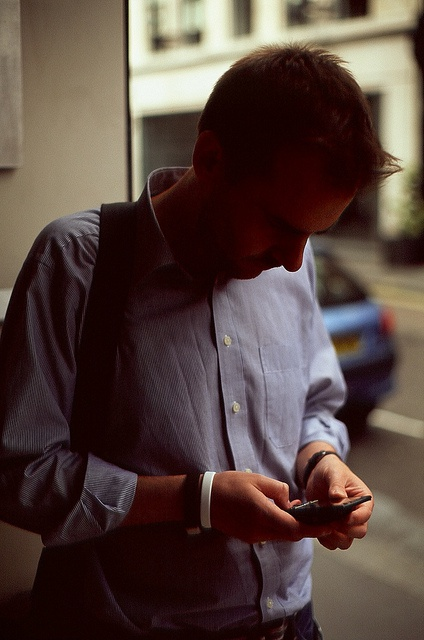Describe the objects in this image and their specific colors. I can see people in gray, black, darkgray, and maroon tones, backpack in gray and black tones, car in gray, black, and maroon tones, and cell phone in gray, black, maroon, and brown tones in this image. 